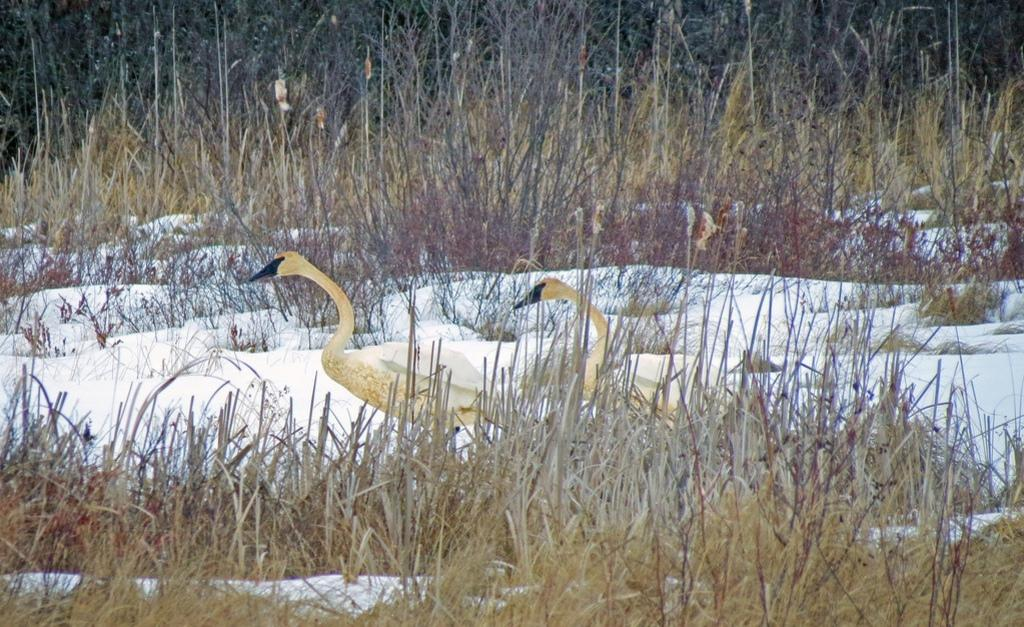How many birds can be seen in the image? There are two birds in the image. Where are the birds located? The birds are on the land. What type of vegetation is present on the land? There is grass on the land. What is the weather like in the image? The presence of snow on the land suggests that it is cold or wintery. What can be seen in the background of the image? There are trees in the background of the image. What type of rings can be seen on the birds' legs in the image? There are no rings visible on the birds' legs in the image. What cable is being used to support the birds in the image? There is no cable present in the image; the birds are standing on the land. 